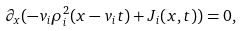<formula> <loc_0><loc_0><loc_500><loc_500>\partial _ { x } ( - v _ { i } \rho _ { i } ^ { 2 } ( x - v _ { i } t ) + J _ { i } ( x , t ) ) = 0 ,</formula> 